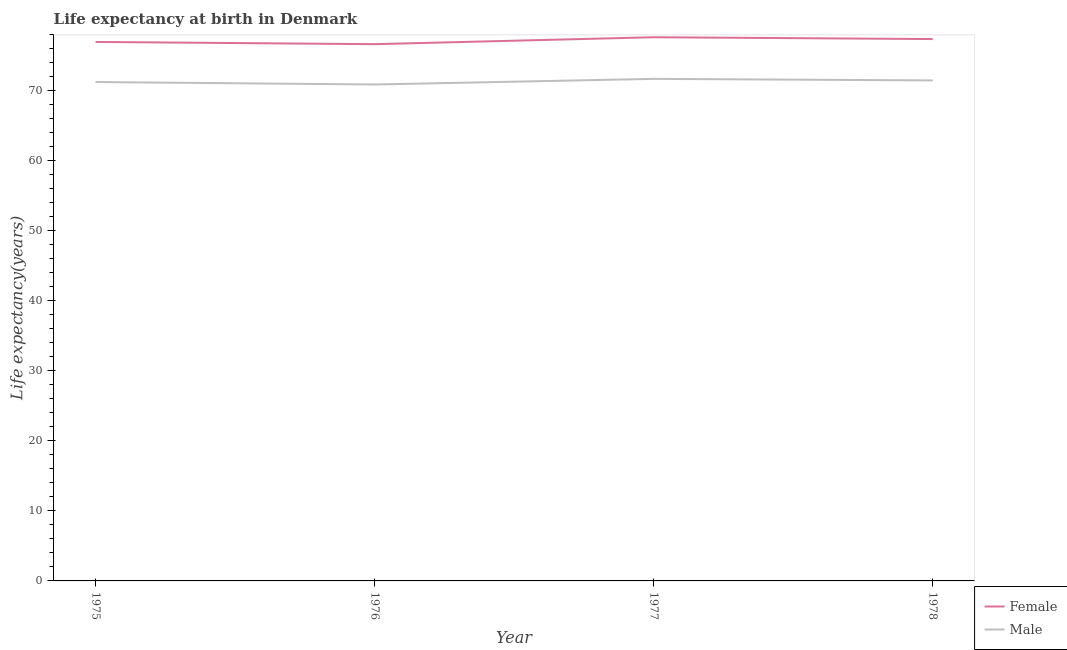What is the life expectancy(male) in 1976?
Provide a succinct answer. 70.93. Across all years, what is the maximum life expectancy(male)?
Your response must be concise. 71.73. Across all years, what is the minimum life expectancy(male)?
Your answer should be compact. 70.93. In which year was the life expectancy(male) maximum?
Offer a terse response. 1977. In which year was the life expectancy(male) minimum?
Keep it short and to the point. 1976. What is the total life expectancy(female) in the graph?
Ensure brevity in your answer.  308.8. What is the difference between the life expectancy(female) in 1975 and that in 1976?
Your answer should be compact. 0.32. What is the difference between the life expectancy(male) in 1976 and the life expectancy(female) in 1975?
Give a very brief answer. -6.08. What is the average life expectancy(female) per year?
Offer a terse response. 77.2. In the year 1977, what is the difference between the life expectancy(male) and life expectancy(female)?
Ensure brevity in your answer.  -5.95. What is the ratio of the life expectancy(female) in 1975 to that in 1978?
Keep it short and to the point. 0.99. Is the life expectancy(male) in 1975 less than that in 1977?
Your answer should be compact. Yes. What is the difference between the highest and the second highest life expectancy(female)?
Provide a succinct answer. 0.26. What is the difference between the highest and the lowest life expectancy(male)?
Your answer should be compact. 0.8. Is the sum of the life expectancy(male) in 1975 and 1976 greater than the maximum life expectancy(female) across all years?
Provide a short and direct response. Yes. Does the life expectancy(female) monotonically increase over the years?
Your answer should be very brief. No. Is the life expectancy(male) strictly greater than the life expectancy(female) over the years?
Your answer should be very brief. No. How many years are there in the graph?
Keep it short and to the point. 4. What is the difference between two consecutive major ticks on the Y-axis?
Keep it short and to the point. 10. Are the values on the major ticks of Y-axis written in scientific E-notation?
Give a very brief answer. No. Does the graph contain any zero values?
Ensure brevity in your answer.  No. Where does the legend appear in the graph?
Offer a very short reply. Bottom right. How are the legend labels stacked?
Provide a short and direct response. Vertical. What is the title of the graph?
Your answer should be compact. Life expectancy at birth in Denmark. What is the label or title of the X-axis?
Your answer should be compact. Year. What is the label or title of the Y-axis?
Give a very brief answer. Life expectancy(years). What is the Life expectancy(years) of Female in 1975?
Your answer should be very brief. 77.01. What is the Life expectancy(years) in Male in 1975?
Offer a terse response. 71.28. What is the Life expectancy(years) of Female in 1976?
Offer a very short reply. 76.69. What is the Life expectancy(years) in Male in 1976?
Your response must be concise. 70.93. What is the Life expectancy(years) of Female in 1977?
Make the answer very short. 77.68. What is the Life expectancy(years) of Male in 1977?
Ensure brevity in your answer.  71.73. What is the Life expectancy(years) in Female in 1978?
Offer a terse response. 77.42. What is the Life expectancy(years) in Male in 1978?
Keep it short and to the point. 71.51. Across all years, what is the maximum Life expectancy(years) of Female?
Make the answer very short. 77.68. Across all years, what is the maximum Life expectancy(years) of Male?
Your response must be concise. 71.73. Across all years, what is the minimum Life expectancy(years) of Female?
Make the answer very short. 76.69. Across all years, what is the minimum Life expectancy(years) in Male?
Offer a very short reply. 70.93. What is the total Life expectancy(years) of Female in the graph?
Ensure brevity in your answer.  308.8. What is the total Life expectancy(years) in Male in the graph?
Keep it short and to the point. 285.45. What is the difference between the Life expectancy(years) in Female in 1975 and that in 1976?
Your answer should be compact. 0.32. What is the difference between the Life expectancy(years) of Male in 1975 and that in 1976?
Provide a succinct answer. 0.35. What is the difference between the Life expectancy(years) in Female in 1975 and that in 1977?
Give a very brief answer. -0.67. What is the difference between the Life expectancy(years) of Male in 1975 and that in 1977?
Keep it short and to the point. -0.45. What is the difference between the Life expectancy(years) in Female in 1975 and that in 1978?
Offer a terse response. -0.41. What is the difference between the Life expectancy(years) of Male in 1975 and that in 1978?
Your answer should be very brief. -0.23. What is the difference between the Life expectancy(years) of Female in 1976 and that in 1977?
Provide a short and direct response. -0.99. What is the difference between the Life expectancy(years) of Male in 1976 and that in 1977?
Give a very brief answer. -0.8. What is the difference between the Life expectancy(years) in Female in 1976 and that in 1978?
Provide a succinct answer. -0.73. What is the difference between the Life expectancy(years) in Male in 1976 and that in 1978?
Keep it short and to the point. -0.58. What is the difference between the Life expectancy(years) in Female in 1977 and that in 1978?
Offer a very short reply. 0.26. What is the difference between the Life expectancy(years) in Male in 1977 and that in 1978?
Ensure brevity in your answer.  0.22. What is the difference between the Life expectancy(years) of Female in 1975 and the Life expectancy(years) of Male in 1976?
Provide a short and direct response. 6.08. What is the difference between the Life expectancy(years) in Female in 1975 and the Life expectancy(years) in Male in 1977?
Keep it short and to the point. 5.28. What is the difference between the Life expectancy(years) of Female in 1975 and the Life expectancy(years) of Male in 1978?
Give a very brief answer. 5.5. What is the difference between the Life expectancy(years) in Female in 1976 and the Life expectancy(years) in Male in 1977?
Your response must be concise. 4.96. What is the difference between the Life expectancy(years) of Female in 1976 and the Life expectancy(years) of Male in 1978?
Your answer should be very brief. 5.18. What is the difference between the Life expectancy(years) in Female in 1977 and the Life expectancy(years) in Male in 1978?
Offer a terse response. 6.17. What is the average Life expectancy(years) in Female per year?
Give a very brief answer. 77.2. What is the average Life expectancy(years) of Male per year?
Make the answer very short. 71.36. In the year 1975, what is the difference between the Life expectancy(years) in Female and Life expectancy(years) in Male?
Make the answer very short. 5.73. In the year 1976, what is the difference between the Life expectancy(years) of Female and Life expectancy(years) of Male?
Your answer should be very brief. 5.76. In the year 1977, what is the difference between the Life expectancy(years) of Female and Life expectancy(years) of Male?
Give a very brief answer. 5.95. In the year 1978, what is the difference between the Life expectancy(years) of Female and Life expectancy(years) of Male?
Your response must be concise. 5.91. What is the ratio of the Life expectancy(years) of Male in 1975 to that in 1976?
Offer a very short reply. 1. What is the ratio of the Life expectancy(years) in Female in 1975 to that in 1977?
Your response must be concise. 0.99. What is the ratio of the Life expectancy(years) in Female in 1975 to that in 1978?
Your response must be concise. 0.99. What is the ratio of the Life expectancy(years) in Female in 1976 to that in 1977?
Ensure brevity in your answer.  0.99. What is the ratio of the Life expectancy(years) of Male in 1976 to that in 1977?
Your response must be concise. 0.99. What is the ratio of the Life expectancy(years) of Female in 1976 to that in 1978?
Make the answer very short. 0.99. What is the ratio of the Life expectancy(years) of Male in 1976 to that in 1978?
Keep it short and to the point. 0.99. What is the ratio of the Life expectancy(years) of Female in 1977 to that in 1978?
Offer a very short reply. 1. What is the difference between the highest and the second highest Life expectancy(years) in Female?
Ensure brevity in your answer.  0.26. What is the difference between the highest and the second highest Life expectancy(years) of Male?
Offer a very short reply. 0.22. 